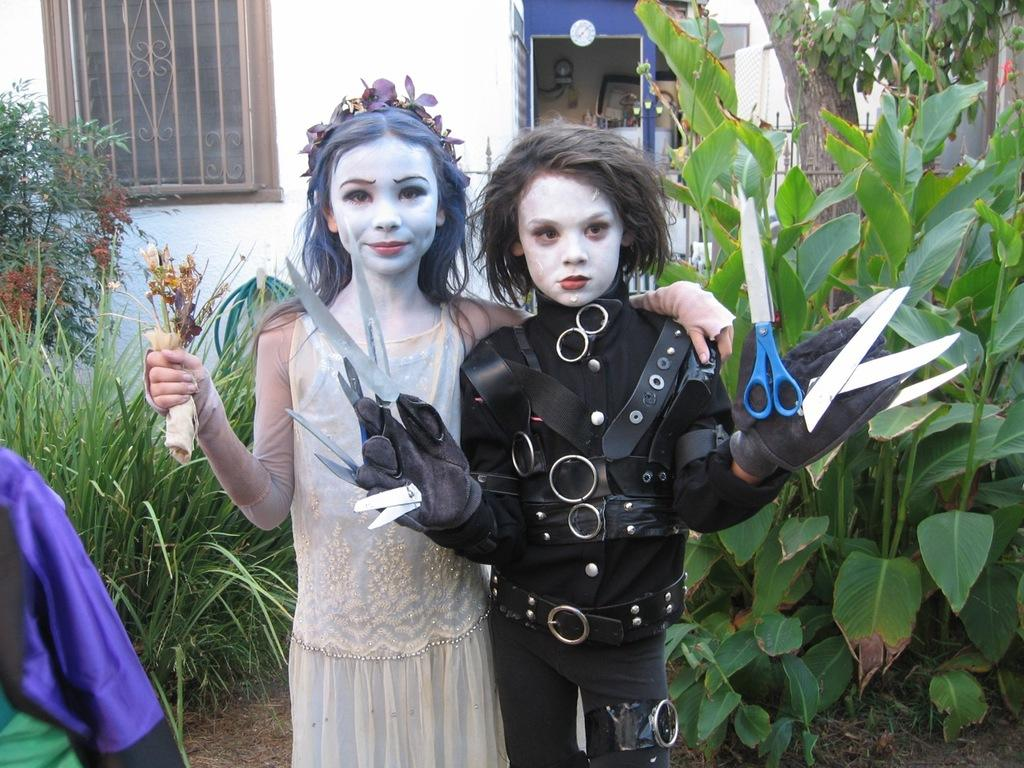How many people are in the image? There are two people standing in the image. What are the people wearing? The people are wearing a white and a black dress. What are the people holding in the image? The people are holding something. What can be seen in the background of the image? There is a building, trees, and windows visible in the background. What color is the wall in the image? The wall is in white color. Can you describe the bee buzzing around the people's heads in the image? There is no bee present in the image; the people are not interacting with any insects. What type of haircut does the person with the white dress have in the image? There is no information about the people's haircuts in the image, as the focus is on their clothing and what they are holding. 